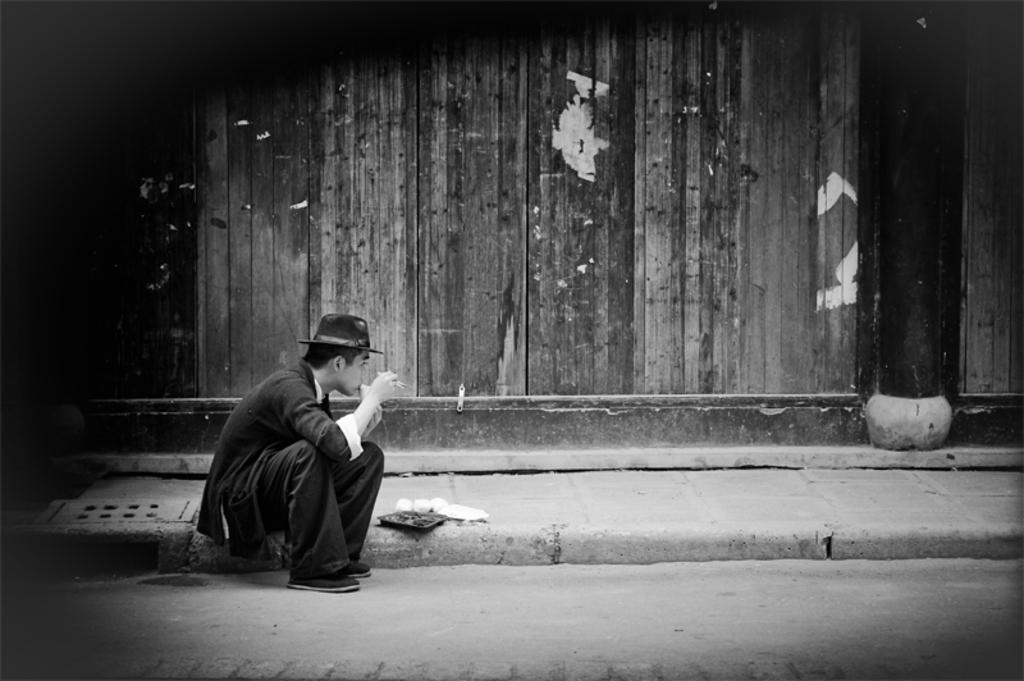Could you give a brief overview of what you see in this image? This picture is black and white. On the left side of the image a man is sitting on footpath and eating some food item. In the background of the image wall is there. At the bottom of the image road is there. In the middle of the image some food item, plate are there. 